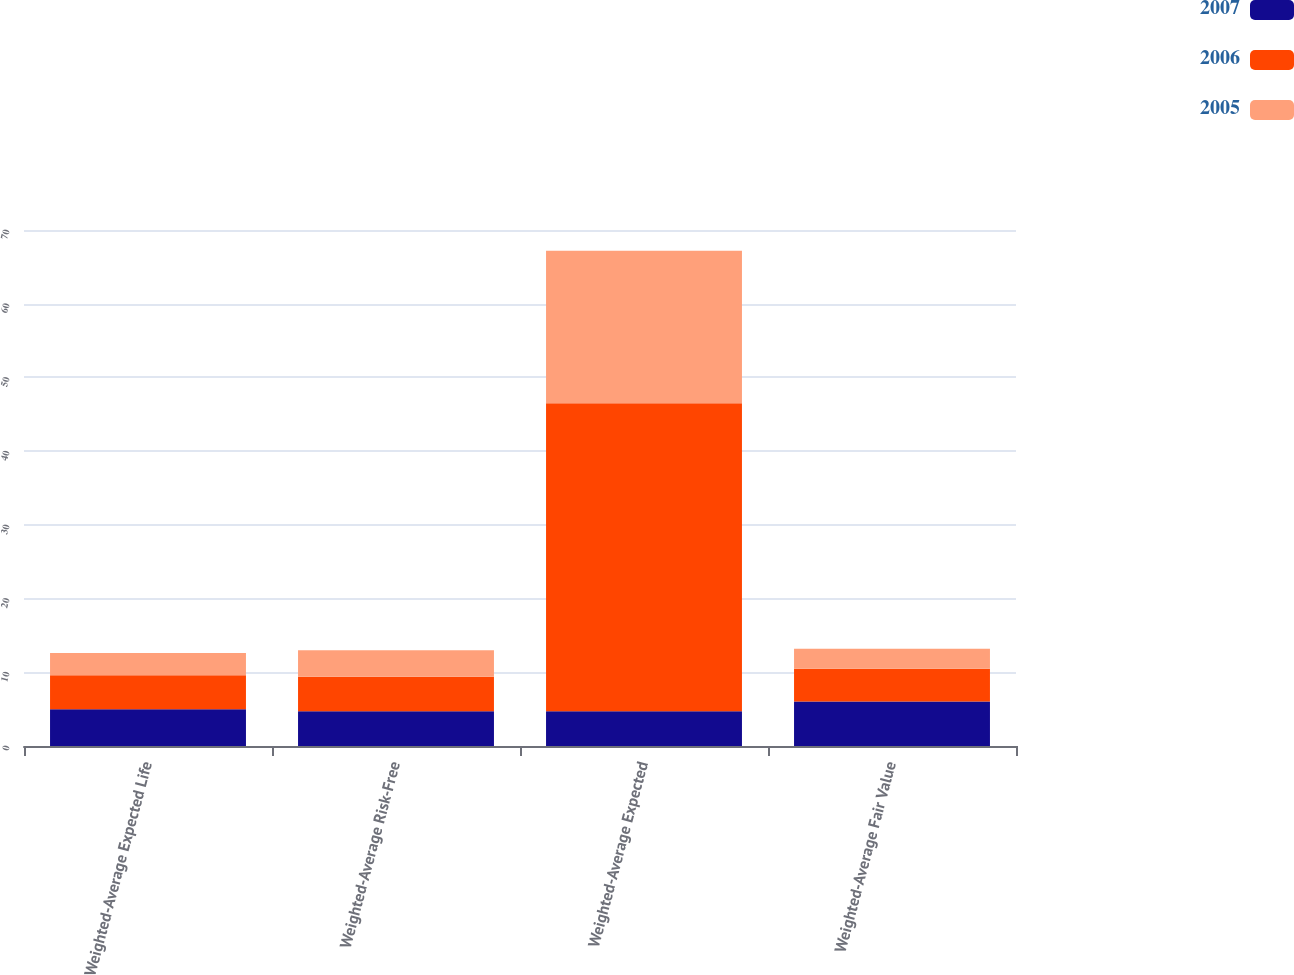Convert chart to OTSL. <chart><loc_0><loc_0><loc_500><loc_500><stacked_bar_chart><ecel><fcel>Weighted-Average Expected Life<fcel>Weighted-Average Risk-Free<fcel>Weighted-Average Expected<fcel>Weighted-Average Fair Value<nl><fcel>2007<fcel>5<fcel>4.7<fcel>4.7<fcel>6.02<nl><fcel>2006<fcel>4.6<fcel>4.7<fcel>41.8<fcel>4.45<nl><fcel>2005<fcel>3<fcel>3.6<fcel>20.7<fcel>2.71<nl></chart> 